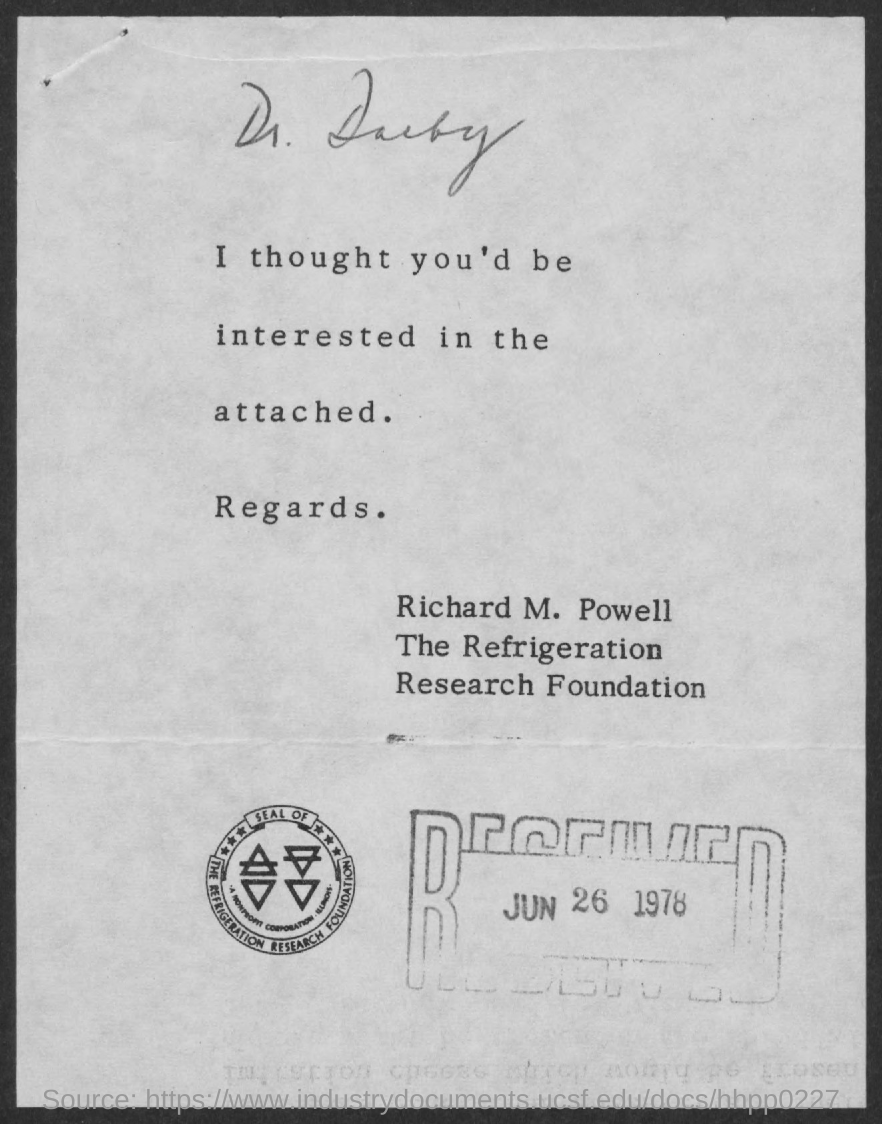What is the received date of this letter?
Ensure brevity in your answer.  JUN 26 1978. Which company seal is given here?
Ensure brevity in your answer.  THE REFRIGERATION RESEARCH FOUNDATION. Who is the sender of this letter?
Offer a terse response. Richard M. Powell. To whom, the letter is addressed?
Your answer should be very brief. Dr. Darby. 